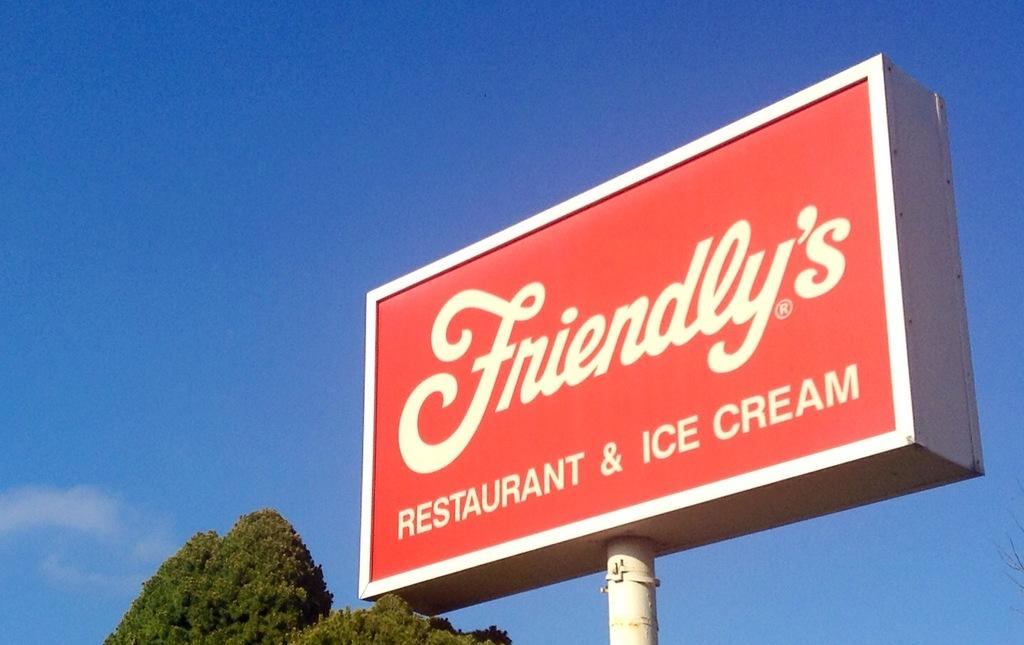<image>
Relay a brief, clear account of the picture shown. a sign for friendly's restaurant and ice cream 